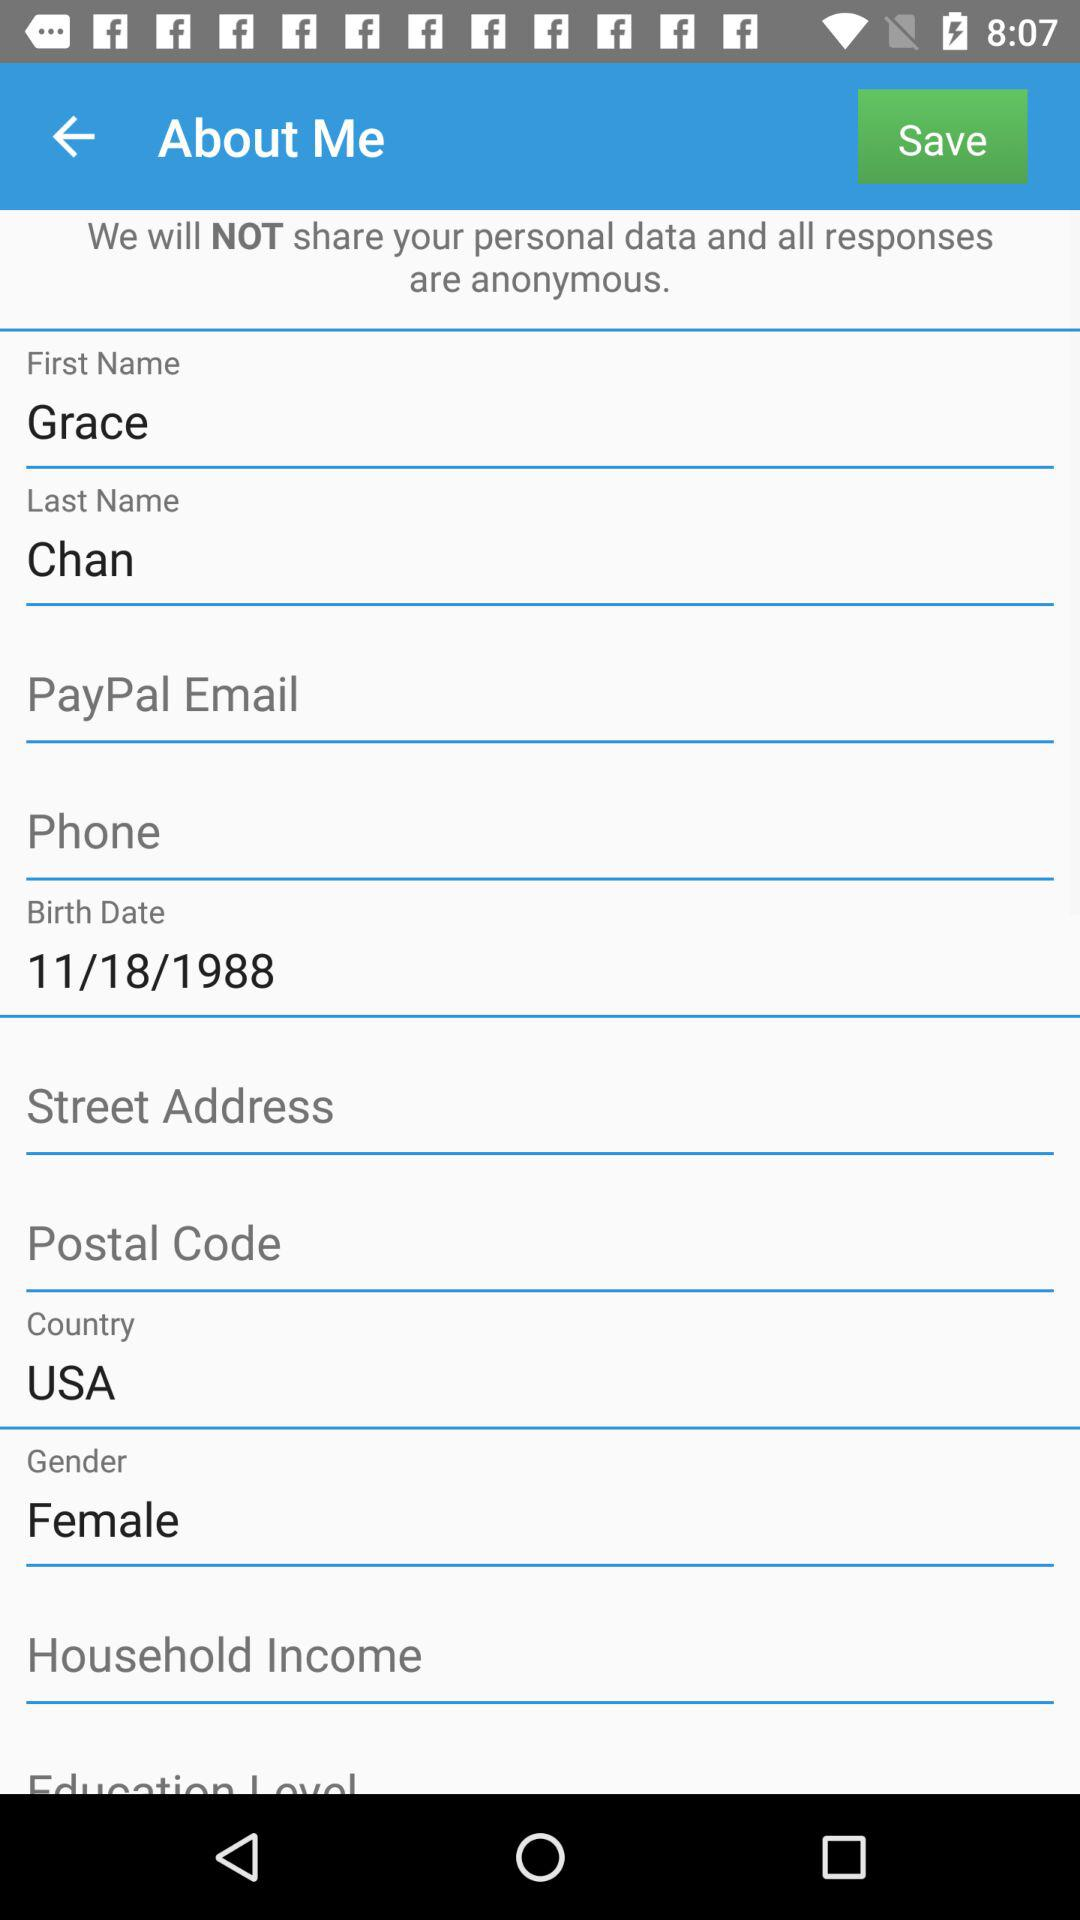What is the birth date? The birth date is November 18, 1988. 